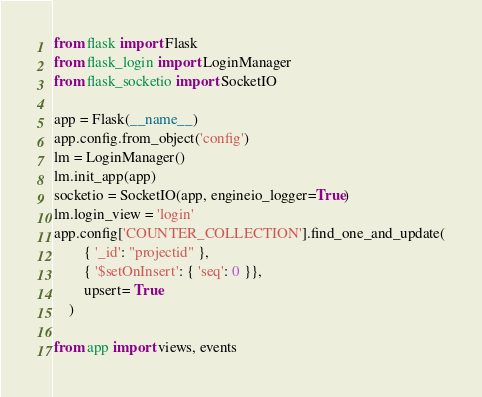<code> <loc_0><loc_0><loc_500><loc_500><_Python_>from flask import Flask
from flask_login import LoginManager
from flask_socketio import SocketIO

app = Flask(__name__)
app.config.from_object('config')
lm = LoginManager()
lm.init_app(app)
socketio = SocketIO(app, engineio_logger=True)
lm.login_view = 'login'
app.config['COUNTER_COLLECTION'].find_one_and_update(
        { '_id': "projectid" },
        { '$setOnInsert': { 'seq': 0 }},
        upsert= True
    )

from app import views, events
</code> 